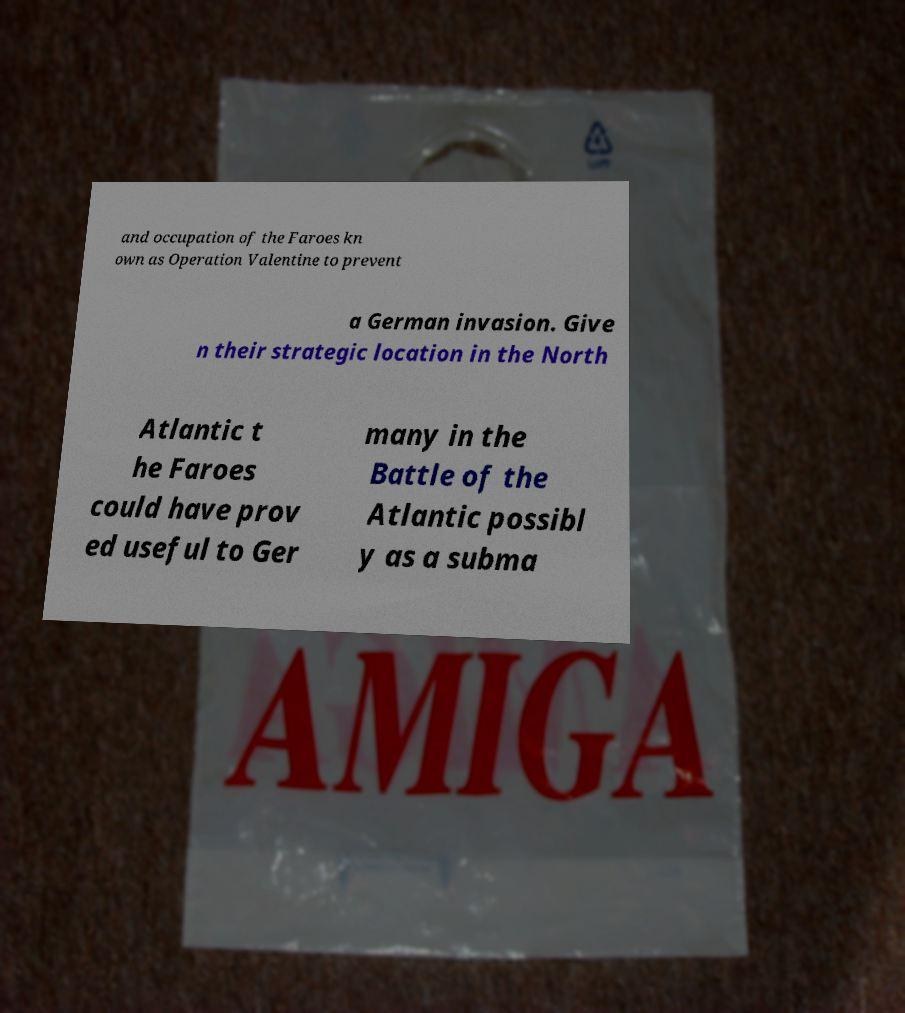What messages or text are displayed in this image? I need them in a readable, typed format. and occupation of the Faroes kn own as Operation Valentine to prevent a German invasion. Give n their strategic location in the North Atlantic t he Faroes could have prov ed useful to Ger many in the Battle of the Atlantic possibl y as a subma 